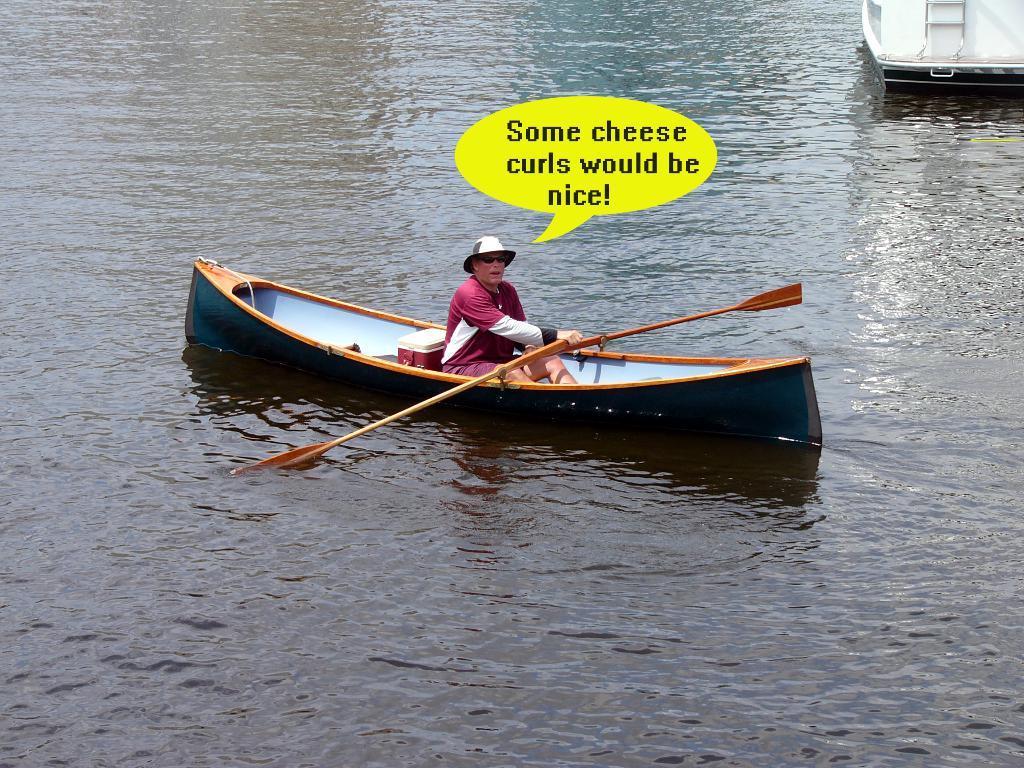In one or two sentences, can you explain what this image depicts? In the image in the center, we can see one boat. In the boat, we can see one person sitting and holding the paddle. In the background we can see water and the boat. 